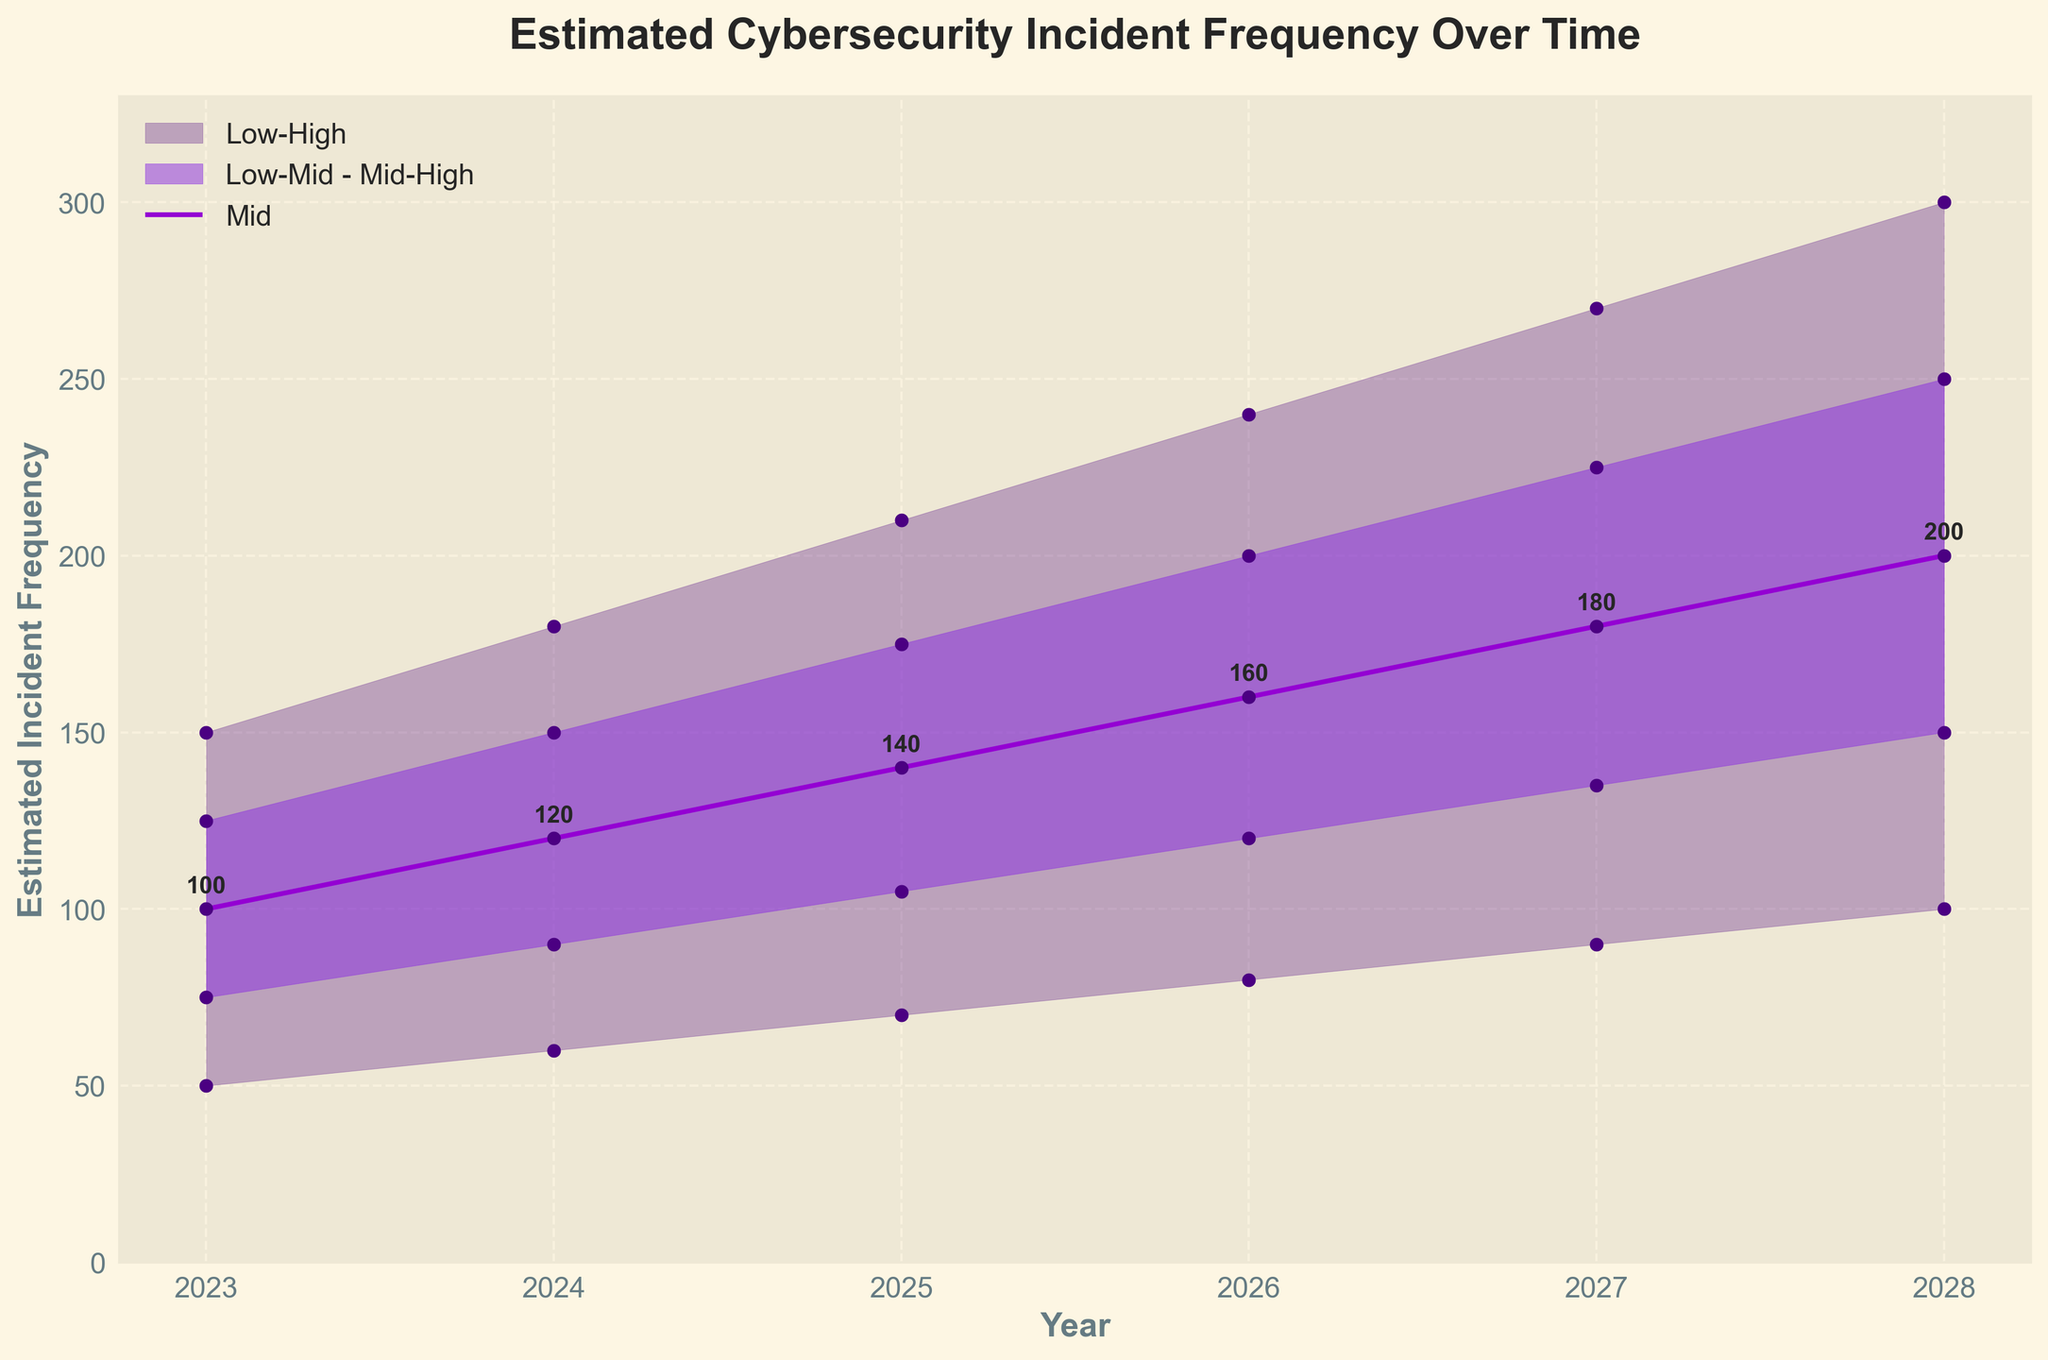what is the title of the figure? The title is located at the top of the plot and is often in a larger and bold font to make it prominent. To note the title, you simply read this text.
Answer: Estimated Cybersecurity Incident Frequency Over Time Which color represents the 'Mid' values in the plot? The 'Mid' values are indicated by a distinct line color, standing out among the filled areas. This allows viewers to quickly identify the average trend line.
Answer: Purple What are the estimated 'Mid' values for the years 2023 and 2024? From the scatter points on the 'Mid' line, observe the y-axis values corresponding to 2023 and 2024. Specifically, these points have annotations indicating their exact numbers.
Answer: 100 and 120 What is the overall trend in the estimated incident frequency from 2023 to 2028? Analyzing the 'Mid' values helps identify the overall trend, as it represents the central estimate. Observe how these values increase over the years.
Answer: Increasing How much does the 'Mid' estimate change from 2023 to 2028? Find the 'Mid' value for 2023 and 2028 from the plot's annotations, and then subtract the 2023 value from the 2028 value to determine the increase.
Answer: 100 What is the range of the estimated incident frequency for the year 2026? For 2026, observe the lower and upper bounds of the shaded area to identify the minimum ('Low') and maximum ('High') estimated frequencies.
Answer: 80 to 240 How does the spread between 'Low' and 'High' estimates change over time? Examine the difference between the 'Low' and 'High' values for each year and notice how it varies. This involves subtracting 'Low' from 'High' for each year.
Answer: Increases Which year has the greatest increase in 'Mid' estimate compared to its previous year? Calculate the increase in 'Mid' estimates between consecutive years and compare these increases. Identify the year with the highest value.
Answer: 2024 Which segment (Low-Mid to Mid-High, etc.) appears to have the most apparent change in shading? Observe the degree of transparency and color overlap in the figure to see which shaded area shows the most noticeable difference as years advance.
Answer: Low-High Describe the confidence range represented in the plot. The plot uses differently shaded areas to show varying levels of confidence. The outermost shaded area represents the highest uncertainty, while the innermost band signifies the central, most confident estimate range.
Answer: Outer shaded shows highest uncertainty, inner bands higher confidence 